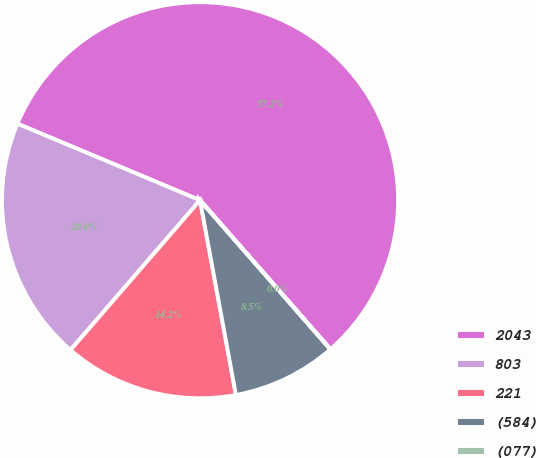<chart> <loc_0><loc_0><loc_500><loc_500><pie_chart><fcel>2043<fcel>803<fcel>221<fcel>(584)<fcel>(077)<nl><fcel>57.24%<fcel>19.97%<fcel>14.25%<fcel>8.53%<fcel>0.01%<nl></chart> 